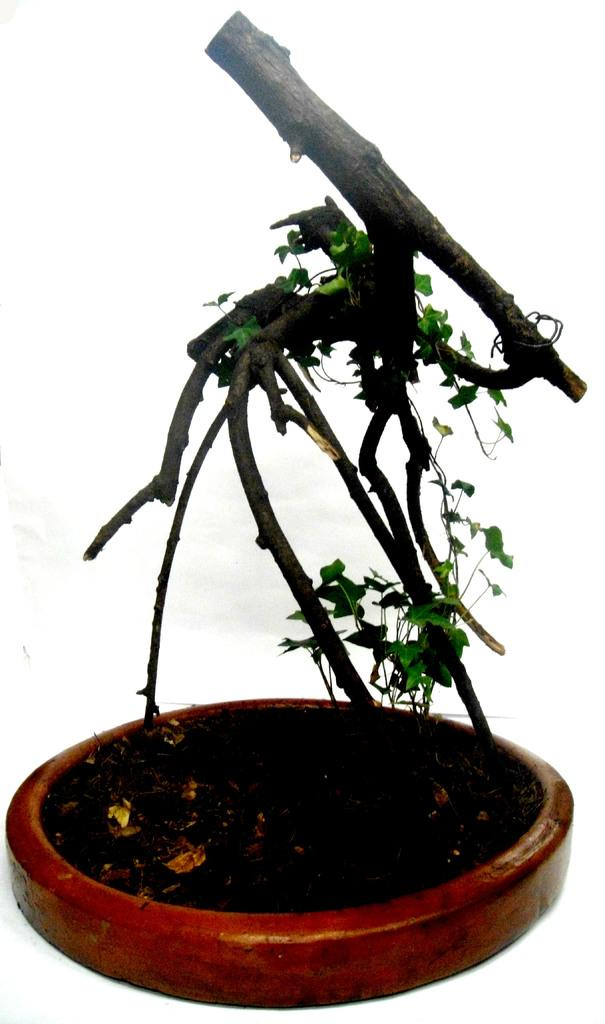What is present in the image? There is a plant in the image. What color is the plant? The plant is green in color. What is the plant placed in? The plant is in a brown object. What color is the background of the image? The background of the image is white. How many holes are visible in the plant in the image? There are no holes visible in the plant in the image; it is a solid plant with no visible holes. 